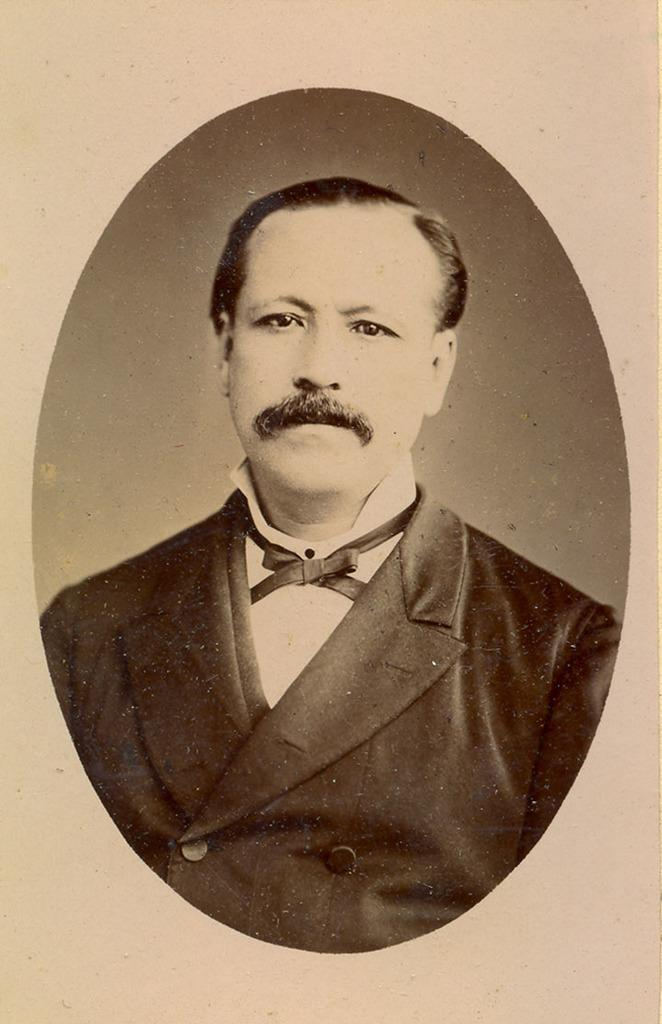What is the medium of the image? The image is on a paper. What is the main subject of the image? There is a sketch of a person in the center of the image. What type of snake is slithering across the stage in the image? There is no snake or stage present in the image; it features a sketch of a person on a paper. 